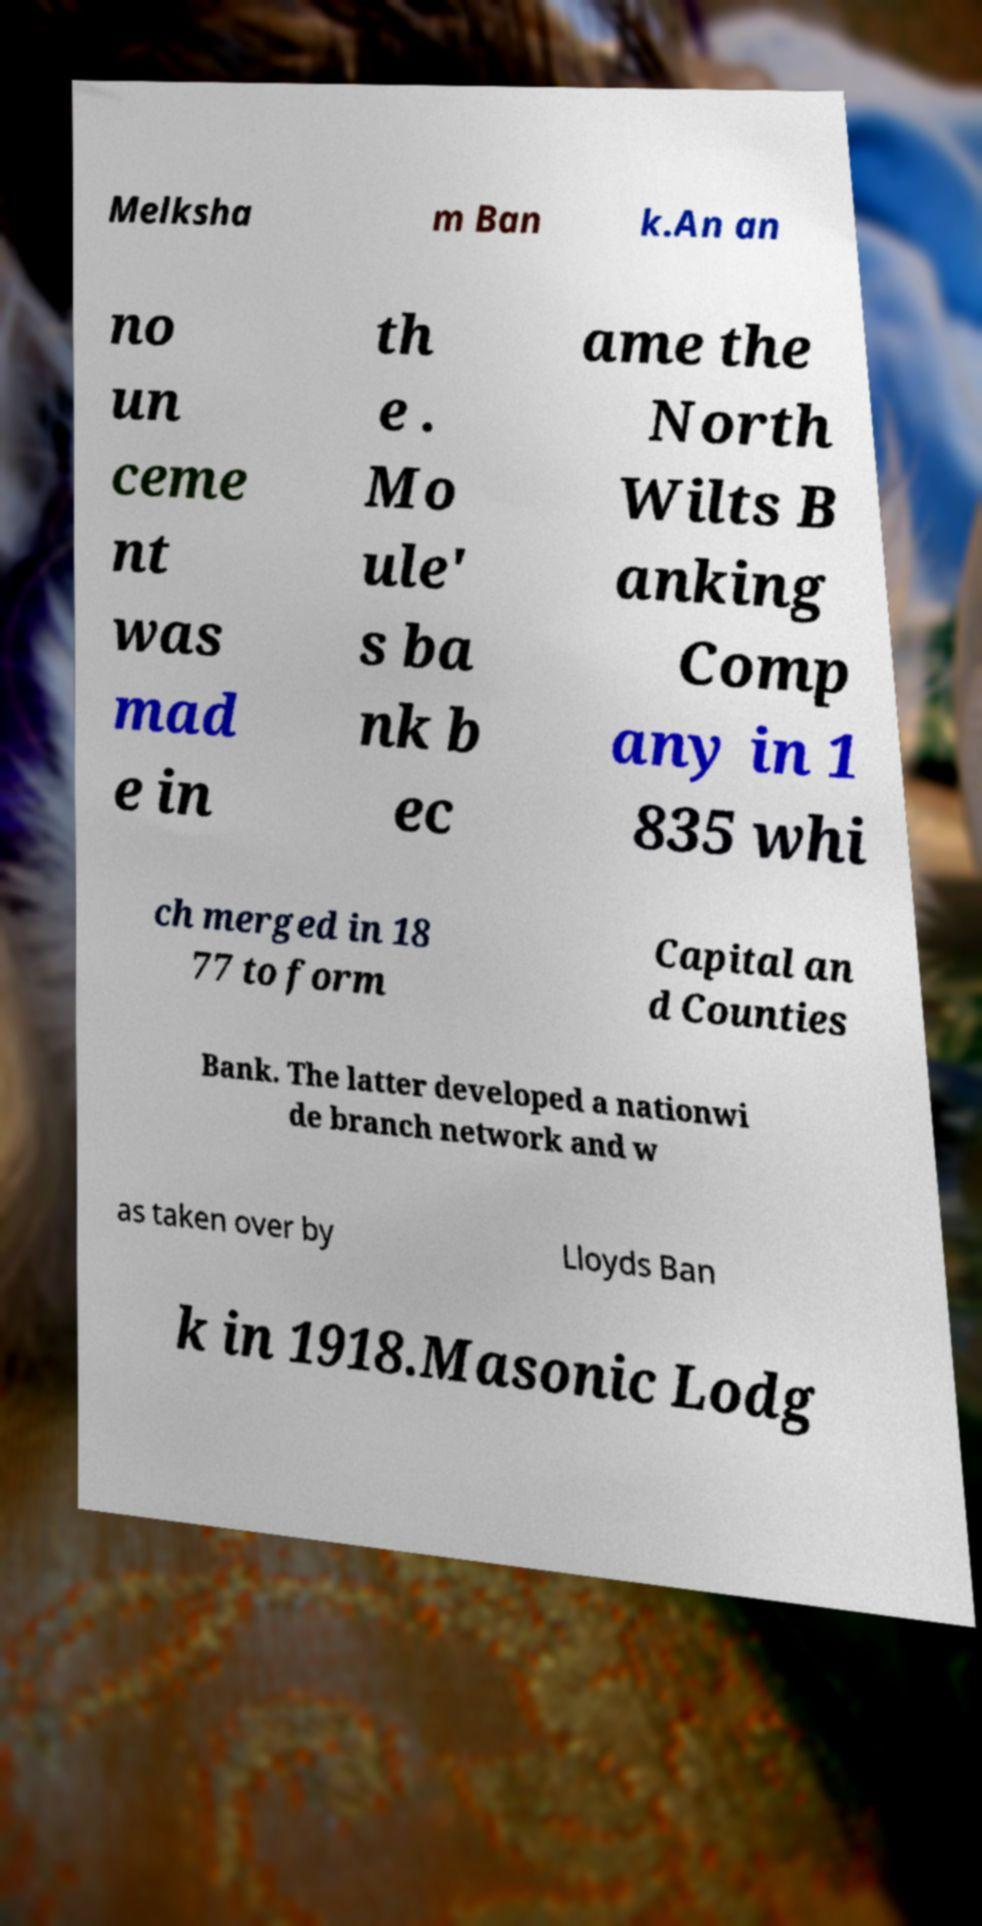There's text embedded in this image that I need extracted. Can you transcribe it verbatim? Melksha m Ban k.An an no un ceme nt was mad e in th e . Mo ule' s ba nk b ec ame the North Wilts B anking Comp any in 1 835 whi ch merged in 18 77 to form Capital an d Counties Bank. The latter developed a nationwi de branch network and w as taken over by Lloyds Ban k in 1918.Masonic Lodg 